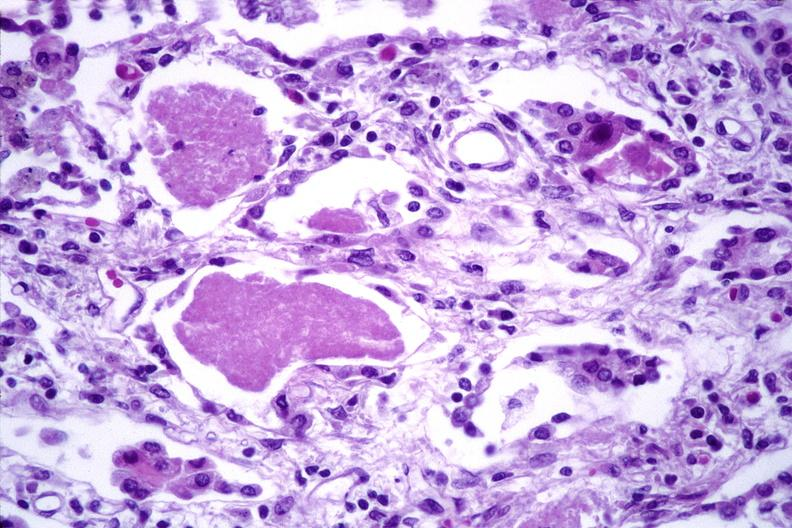what does this image show?
Answer the question using a single word or phrase. Lung 